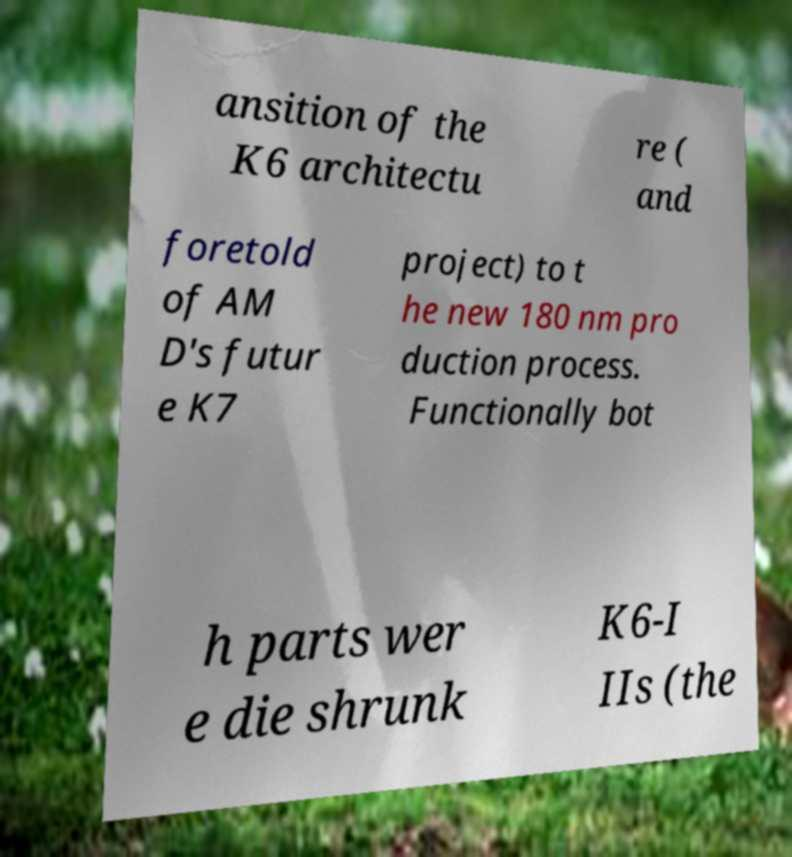Can you read and provide the text displayed in the image?This photo seems to have some interesting text. Can you extract and type it out for me? ansition of the K6 architectu re ( and foretold of AM D's futur e K7 project) to t he new 180 nm pro duction process. Functionally bot h parts wer e die shrunk K6-I IIs (the 